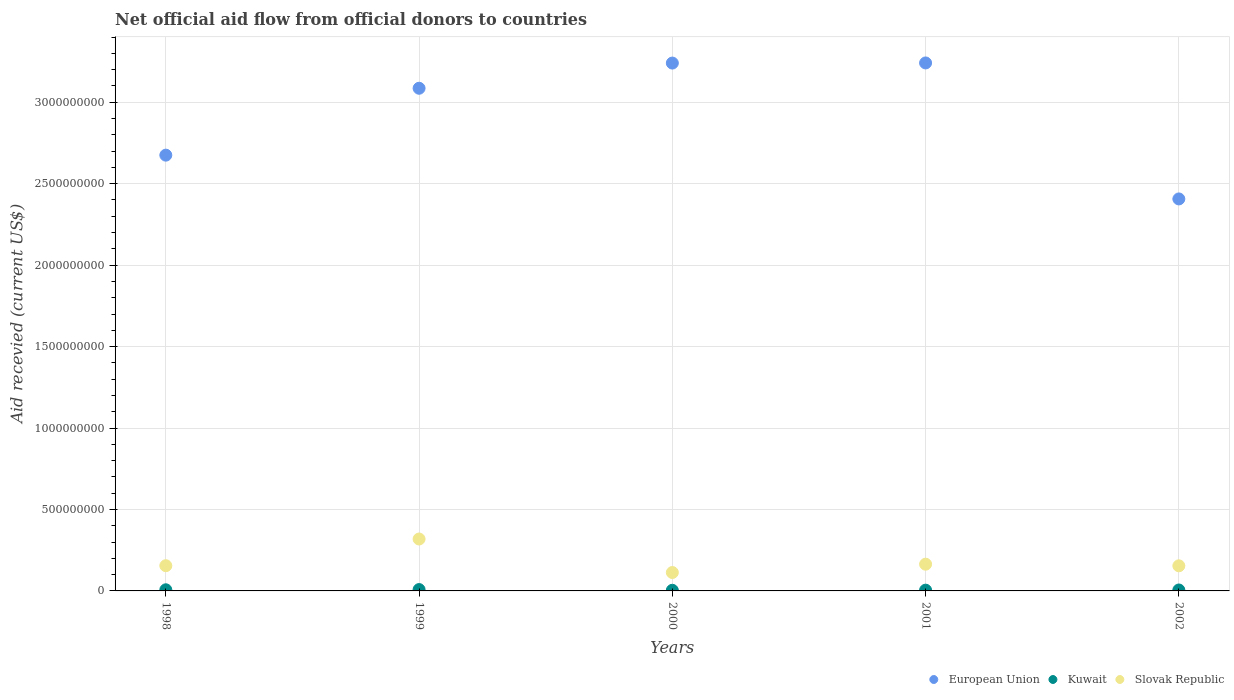How many different coloured dotlines are there?
Offer a terse response. 3. Is the number of dotlines equal to the number of legend labels?
Ensure brevity in your answer.  Yes. What is the total aid received in Slovak Republic in 2002?
Ensure brevity in your answer.  1.54e+08. Across all years, what is the maximum total aid received in European Union?
Provide a short and direct response. 3.24e+09. Across all years, what is the minimum total aid received in Kuwait?
Your answer should be compact. 3.89e+06. In which year was the total aid received in Slovak Republic maximum?
Your answer should be compact. 1999. In which year was the total aid received in Slovak Republic minimum?
Provide a succinct answer. 2000. What is the total total aid received in European Union in the graph?
Your answer should be compact. 1.46e+1. What is the difference between the total aid received in European Union in 1999 and that in 2001?
Your answer should be very brief. -1.55e+08. What is the difference between the total aid received in Kuwait in 1998 and the total aid received in Slovak Republic in 2000?
Provide a succinct answer. -1.06e+08. What is the average total aid received in Slovak Republic per year?
Provide a short and direct response. 1.81e+08. In the year 1999, what is the difference between the total aid received in Kuwait and total aid received in Slovak Republic?
Keep it short and to the point. -3.10e+08. In how many years, is the total aid received in European Union greater than 1400000000 US$?
Your response must be concise. 5. What is the ratio of the total aid received in Kuwait in 1999 to that in 2001?
Offer a very short reply. 1.78. Is the total aid received in Slovak Republic in 2000 less than that in 2001?
Provide a short and direct response. Yes. What is the difference between the highest and the second highest total aid received in Slovak Republic?
Provide a succinct answer. 1.55e+08. What is the difference between the highest and the lowest total aid received in Slovak Republic?
Provide a succinct answer. 2.06e+08. In how many years, is the total aid received in European Union greater than the average total aid received in European Union taken over all years?
Provide a short and direct response. 3. Does the total aid received in Kuwait monotonically increase over the years?
Offer a terse response. No. Is the total aid received in Kuwait strictly greater than the total aid received in European Union over the years?
Your answer should be compact. No. Is the total aid received in European Union strictly less than the total aid received in Slovak Republic over the years?
Provide a short and direct response. No. How many dotlines are there?
Offer a terse response. 3. How many years are there in the graph?
Make the answer very short. 5. What is the difference between two consecutive major ticks on the Y-axis?
Provide a short and direct response. 5.00e+08. Does the graph contain grids?
Make the answer very short. Yes. Where does the legend appear in the graph?
Your answer should be compact. Bottom right. How many legend labels are there?
Give a very brief answer. 3. How are the legend labels stacked?
Provide a short and direct response. Horizontal. What is the title of the graph?
Ensure brevity in your answer.  Net official aid flow from official donors to countries. Does "Cabo Verde" appear as one of the legend labels in the graph?
Your response must be concise. No. What is the label or title of the Y-axis?
Keep it short and to the point. Aid recevied (current US$). What is the Aid recevied (current US$) of European Union in 1998?
Your answer should be compact. 2.68e+09. What is the Aid recevied (current US$) of Kuwait in 1998?
Ensure brevity in your answer.  6.99e+06. What is the Aid recevied (current US$) in Slovak Republic in 1998?
Make the answer very short. 1.55e+08. What is the Aid recevied (current US$) of European Union in 1999?
Give a very brief answer. 3.09e+09. What is the Aid recevied (current US$) in Kuwait in 1999?
Make the answer very short. 8.33e+06. What is the Aid recevied (current US$) in Slovak Republic in 1999?
Keep it short and to the point. 3.19e+08. What is the Aid recevied (current US$) of European Union in 2000?
Offer a very short reply. 3.24e+09. What is the Aid recevied (current US$) in Kuwait in 2000?
Make the answer very short. 3.89e+06. What is the Aid recevied (current US$) of Slovak Republic in 2000?
Your answer should be very brief. 1.13e+08. What is the Aid recevied (current US$) in European Union in 2001?
Provide a succinct answer. 3.24e+09. What is the Aid recevied (current US$) in Kuwait in 2001?
Provide a succinct answer. 4.69e+06. What is the Aid recevied (current US$) of Slovak Republic in 2001?
Offer a terse response. 1.64e+08. What is the Aid recevied (current US$) in European Union in 2002?
Your response must be concise. 2.41e+09. What is the Aid recevied (current US$) in Kuwait in 2002?
Provide a succinct answer. 5.71e+06. What is the Aid recevied (current US$) in Slovak Republic in 2002?
Keep it short and to the point. 1.54e+08. Across all years, what is the maximum Aid recevied (current US$) of European Union?
Give a very brief answer. 3.24e+09. Across all years, what is the maximum Aid recevied (current US$) in Kuwait?
Make the answer very short. 8.33e+06. Across all years, what is the maximum Aid recevied (current US$) in Slovak Republic?
Provide a succinct answer. 3.19e+08. Across all years, what is the minimum Aid recevied (current US$) of European Union?
Your answer should be very brief. 2.41e+09. Across all years, what is the minimum Aid recevied (current US$) of Kuwait?
Your answer should be very brief. 3.89e+06. Across all years, what is the minimum Aid recevied (current US$) of Slovak Republic?
Give a very brief answer. 1.13e+08. What is the total Aid recevied (current US$) of European Union in the graph?
Make the answer very short. 1.46e+1. What is the total Aid recevied (current US$) of Kuwait in the graph?
Your response must be concise. 2.96e+07. What is the total Aid recevied (current US$) of Slovak Republic in the graph?
Provide a succinct answer. 9.05e+08. What is the difference between the Aid recevied (current US$) in European Union in 1998 and that in 1999?
Your answer should be very brief. -4.11e+08. What is the difference between the Aid recevied (current US$) in Kuwait in 1998 and that in 1999?
Offer a terse response. -1.34e+06. What is the difference between the Aid recevied (current US$) in Slovak Republic in 1998 and that in 1999?
Provide a succinct answer. -1.64e+08. What is the difference between the Aid recevied (current US$) of European Union in 1998 and that in 2000?
Your answer should be compact. -5.65e+08. What is the difference between the Aid recevied (current US$) of Kuwait in 1998 and that in 2000?
Your answer should be compact. 3.10e+06. What is the difference between the Aid recevied (current US$) of Slovak Republic in 1998 and that in 2000?
Provide a succinct answer. 4.18e+07. What is the difference between the Aid recevied (current US$) of European Union in 1998 and that in 2001?
Offer a very short reply. -5.66e+08. What is the difference between the Aid recevied (current US$) of Kuwait in 1998 and that in 2001?
Your answer should be very brief. 2.30e+06. What is the difference between the Aid recevied (current US$) of Slovak Republic in 1998 and that in 2001?
Your response must be concise. -9.22e+06. What is the difference between the Aid recevied (current US$) in European Union in 1998 and that in 2002?
Give a very brief answer. 2.69e+08. What is the difference between the Aid recevied (current US$) in Kuwait in 1998 and that in 2002?
Offer a terse response. 1.28e+06. What is the difference between the Aid recevied (current US$) of European Union in 1999 and that in 2000?
Your response must be concise. -1.55e+08. What is the difference between the Aid recevied (current US$) of Kuwait in 1999 and that in 2000?
Your response must be concise. 4.44e+06. What is the difference between the Aid recevied (current US$) of Slovak Republic in 1999 and that in 2000?
Give a very brief answer. 2.06e+08. What is the difference between the Aid recevied (current US$) in European Union in 1999 and that in 2001?
Make the answer very short. -1.55e+08. What is the difference between the Aid recevied (current US$) of Kuwait in 1999 and that in 2001?
Your response must be concise. 3.64e+06. What is the difference between the Aid recevied (current US$) in Slovak Republic in 1999 and that in 2001?
Offer a terse response. 1.55e+08. What is the difference between the Aid recevied (current US$) in European Union in 1999 and that in 2002?
Provide a succinct answer. 6.79e+08. What is the difference between the Aid recevied (current US$) in Kuwait in 1999 and that in 2002?
Ensure brevity in your answer.  2.62e+06. What is the difference between the Aid recevied (current US$) in Slovak Republic in 1999 and that in 2002?
Offer a terse response. 1.65e+08. What is the difference between the Aid recevied (current US$) in European Union in 2000 and that in 2001?
Provide a short and direct response. -7.70e+05. What is the difference between the Aid recevied (current US$) in Kuwait in 2000 and that in 2001?
Give a very brief answer. -8.00e+05. What is the difference between the Aid recevied (current US$) in Slovak Republic in 2000 and that in 2001?
Your answer should be very brief. -5.10e+07. What is the difference between the Aid recevied (current US$) of European Union in 2000 and that in 2002?
Your answer should be compact. 8.34e+08. What is the difference between the Aid recevied (current US$) in Kuwait in 2000 and that in 2002?
Offer a terse response. -1.82e+06. What is the difference between the Aid recevied (current US$) of Slovak Republic in 2000 and that in 2002?
Keep it short and to the point. -4.11e+07. What is the difference between the Aid recevied (current US$) of European Union in 2001 and that in 2002?
Your answer should be compact. 8.35e+08. What is the difference between the Aid recevied (current US$) of Kuwait in 2001 and that in 2002?
Make the answer very short. -1.02e+06. What is the difference between the Aid recevied (current US$) of Slovak Republic in 2001 and that in 2002?
Ensure brevity in your answer.  9.92e+06. What is the difference between the Aid recevied (current US$) of European Union in 1998 and the Aid recevied (current US$) of Kuwait in 1999?
Your response must be concise. 2.67e+09. What is the difference between the Aid recevied (current US$) of European Union in 1998 and the Aid recevied (current US$) of Slovak Republic in 1999?
Offer a very short reply. 2.36e+09. What is the difference between the Aid recevied (current US$) in Kuwait in 1998 and the Aid recevied (current US$) in Slovak Republic in 1999?
Ensure brevity in your answer.  -3.12e+08. What is the difference between the Aid recevied (current US$) of European Union in 1998 and the Aid recevied (current US$) of Kuwait in 2000?
Your answer should be very brief. 2.67e+09. What is the difference between the Aid recevied (current US$) in European Union in 1998 and the Aid recevied (current US$) in Slovak Republic in 2000?
Provide a short and direct response. 2.56e+09. What is the difference between the Aid recevied (current US$) of Kuwait in 1998 and the Aid recevied (current US$) of Slovak Republic in 2000?
Offer a very short reply. -1.06e+08. What is the difference between the Aid recevied (current US$) in European Union in 1998 and the Aid recevied (current US$) in Kuwait in 2001?
Ensure brevity in your answer.  2.67e+09. What is the difference between the Aid recevied (current US$) of European Union in 1998 and the Aid recevied (current US$) of Slovak Republic in 2001?
Ensure brevity in your answer.  2.51e+09. What is the difference between the Aid recevied (current US$) of Kuwait in 1998 and the Aid recevied (current US$) of Slovak Republic in 2001?
Give a very brief answer. -1.57e+08. What is the difference between the Aid recevied (current US$) in European Union in 1998 and the Aid recevied (current US$) in Kuwait in 2002?
Your answer should be very brief. 2.67e+09. What is the difference between the Aid recevied (current US$) in European Union in 1998 and the Aid recevied (current US$) in Slovak Republic in 2002?
Ensure brevity in your answer.  2.52e+09. What is the difference between the Aid recevied (current US$) in Kuwait in 1998 and the Aid recevied (current US$) in Slovak Republic in 2002?
Give a very brief answer. -1.47e+08. What is the difference between the Aid recevied (current US$) of European Union in 1999 and the Aid recevied (current US$) of Kuwait in 2000?
Keep it short and to the point. 3.08e+09. What is the difference between the Aid recevied (current US$) of European Union in 1999 and the Aid recevied (current US$) of Slovak Republic in 2000?
Your response must be concise. 2.97e+09. What is the difference between the Aid recevied (current US$) in Kuwait in 1999 and the Aid recevied (current US$) in Slovak Republic in 2000?
Ensure brevity in your answer.  -1.05e+08. What is the difference between the Aid recevied (current US$) of European Union in 1999 and the Aid recevied (current US$) of Kuwait in 2001?
Offer a very short reply. 3.08e+09. What is the difference between the Aid recevied (current US$) in European Union in 1999 and the Aid recevied (current US$) in Slovak Republic in 2001?
Give a very brief answer. 2.92e+09. What is the difference between the Aid recevied (current US$) of Kuwait in 1999 and the Aid recevied (current US$) of Slovak Republic in 2001?
Your answer should be very brief. -1.56e+08. What is the difference between the Aid recevied (current US$) of European Union in 1999 and the Aid recevied (current US$) of Kuwait in 2002?
Your response must be concise. 3.08e+09. What is the difference between the Aid recevied (current US$) in European Union in 1999 and the Aid recevied (current US$) in Slovak Republic in 2002?
Provide a short and direct response. 2.93e+09. What is the difference between the Aid recevied (current US$) in Kuwait in 1999 and the Aid recevied (current US$) in Slovak Republic in 2002?
Provide a succinct answer. -1.46e+08. What is the difference between the Aid recevied (current US$) in European Union in 2000 and the Aid recevied (current US$) in Kuwait in 2001?
Offer a very short reply. 3.24e+09. What is the difference between the Aid recevied (current US$) of European Union in 2000 and the Aid recevied (current US$) of Slovak Republic in 2001?
Give a very brief answer. 3.08e+09. What is the difference between the Aid recevied (current US$) of Kuwait in 2000 and the Aid recevied (current US$) of Slovak Republic in 2001?
Keep it short and to the point. -1.60e+08. What is the difference between the Aid recevied (current US$) in European Union in 2000 and the Aid recevied (current US$) in Kuwait in 2002?
Give a very brief answer. 3.23e+09. What is the difference between the Aid recevied (current US$) of European Union in 2000 and the Aid recevied (current US$) of Slovak Republic in 2002?
Ensure brevity in your answer.  3.09e+09. What is the difference between the Aid recevied (current US$) of Kuwait in 2000 and the Aid recevied (current US$) of Slovak Republic in 2002?
Ensure brevity in your answer.  -1.50e+08. What is the difference between the Aid recevied (current US$) in European Union in 2001 and the Aid recevied (current US$) in Kuwait in 2002?
Offer a very short reply. 3.24e+09. What is the difference between the Aid recevied (current US$) of European Union in 2001 and the Aid recevied (current US$) of Slovak Republic in 2002?
Provide a succinct answer. 3.09e+09. What is the difference between the Aid recevied (current US$) of Kuwait in 2001 and the Aid recevied (current US$) of Slovak Republic in 2002?
Your response must be concise. -1.49e+08. What is the average Aid recevied (current US$) of European Union per year?
Your answer should be compact. 2.93e+09. What is the average Aid recevied (current US$) in Kuwait per year?
Give a very brief answer. 5.92e+06. What is the average Aid recevied (current US$) of Slovak Republic per year?
Your answer should be very brief. 1.81e+08. In the year 1998, what is the difference between the Aid recevied (current US$) in European Union and Aid recevied (current US$) in Kuwait?
Your answer should be very brief. 2.67e+09. In the year 1998, what is the difference between the Aid recevied (current US$) of European Union and Aid recevied (current US$) of Slovak Republic?
Make the answer very short. 2.52e+09. In the year 1998, what is the difference between the Aid recevied (current US$) in Kuwait and Aid recevied (current US$) in Slovak Republic?
Give a very brief answer. -1.48e+08. In the year 1999, what is the difference between the Aid recevied (current US$) in European Union and Aid recevied (current US$) in Kuwait?
Your response must be concise. 3.08e+09. In the year 1999, what is the difference between the Aid recevied (current US$) of European Union and Aid recevied (current US$) of Slovak Republic?
Offer a terse response. 2.77e+09. In the year 1999, what is the difference between the Aid recevied (current US$) in Kuwait and Aid recevied (current US$) in Slovak Republic?
Your answer should be compact. -3.10e+08. In the year 2000, what is the difference between the Aid recevied (current US$) of European Union and Aid recevied (current US$) of Kuwait?
Offer a terse response. 3.24e+09. In the year 2000, what is the difference between the Aid recevied (current US$) of European Union and Aid recevied (current US$) of Slovak Republic?
Provide a succinct answer. 3.13e+09. In the year 2000, what is the difference between the Aid recevied (current US$) of Kuwait and Aid recevied (current US$) of Slovak Republic?
Your response must be concise. -1.09e+08. In the year 2001, what is the difference between the Aid recevied (current US$) in European Union and Aid recevied (current US$) in Kuwait?
Your answer should be very brief. 3.24e+09. In the year 2001, what is the difference between the Aid recevied (current US$) in European Union and Aid recevied (current US$) in Slovak Republic?
Offer a terse response. 3.08e+09. In the year 2001, what is the difference between the Aid recevied (current US$) in Kuwait and Aid recevied (current US$) in Slovak Republic?
Give a very brief answer. -1.59e+08. In the year 2002, what is the difference between the Aid recevied (current US$) in European Union and Aid recevied (current US$) in Kuwait?
Keep it short and to the point. 2.40e+09. In the year 2002, what is the difference between the Aid recevied (current US$) in European Union and Aid recevied (current US$) in Slovak Republic?
Give a very brief answer. 2.25e+09. In the year 2002, what is the difference between the Aid recevied (current US$) in Kuwait and Aid recevied (current US$) in Slovak Republic?
Your answer should be compact. -1.48e+08. What is the ratio of the Aid recevied (current US$) of European Union in 1998 to that in 1999?
Your answer should be compact. 0.87. What is the ratio of the Aid recevied (current US$) in Kuwait in 1998 to that in 1999?
Provide a succinct answer. 0.84. What is the ratio of the Aid recevied (current US$) of Slovak Republic in 1998 to that in 1999?
Ensure brevity in your answer.  0.49. What is the ratio of the Aid recevied (current US$) of European Union in 1998 to that in 2000?
Your answer should be compact. 0.83. What is the ratio of the Aid recevied (current US$) in Kuwait in 1998 to that in 2000?
Make the answer very short. 1.8. What is the ratio of the Aid recevied (current US$) in Slovak Republic in 1998 to that in 2000?
Your answer should be very brief. 1.37. What is the ratio of the Aid recevied (current US$) of European Union in 1998 to that in 2001?
Your answer should be compact. 0.83. What is the ratio of the Aid recevied (current US$) in Kuwait in 1998 to that in 2001?
Ensure brevity in your answer.  1.49. What is the ratio of the Aid recevied (current US$) of Slovak Republic in 1998 to that in 2001?
Your answer should be very brief. 0.94. What is the ratio of the Aid recevied (current US$) of European Union in 1998 to that in 2002?
Give a very brief answer. 1.11. What is the ratio of the Aid recevied (current US$) in Kuwait in 1998 to that in 2002?
Your response must be concise. 1.22. What is the ratio of the Aid recevied (current US$) in European Union in 1999 to that in 2000?
Keep it short and to the point. 0.95. What is the ratio of the Aid recevied (current US$) in Kuwait in 1999 to that in 2000?
Your answer should be compact. 2.14. What is the ratio of the Aid recevied (current US$) in Slovak Republic in 1999 to that in 2000?
Give a very brief answer. 2.82. What is the ratio of the Aid recevied (current US$) in European Union in 1999 to that in 2001?
Offer a terse response. 0.95. What is the ratio of the Aid recevied (current US$) in Kuwait in 1999 to that in 2001?
Your answer should be compact. 1.78. What is the ratio of the Aid recevied (current US$) in Slovak Republic in 1999 to that in 2001?
Your answer should be very brief. 1.94. What is the ratio of the Aid recevied (current US$) in European Union in 1999 to that in 2002?
Your response must be concise. 1.28. What is the ratio of the Aid recevied (current US$) in Kuwait in 1999 to that in 2002?
Give a very brief answer. 1.46. What is the ratio of the Aid recevied (current US$) of Slovak Republic in 1999 to that in 2002?
Your answer should be very brief. 2.07. What is the ratio of the Aid recevied (current US$) in European Union in 2000 to that in 2001?
Ensure brevity in your answer.  1. What is the ratio of the Aid recevied (current US$) in Kuwait in 2000 to that in 2001?
Your answer should be very brief. 0.83. What is the ratio of the Aid recevied (current US$) in Slovak Republic in 2000 to that in 2001?
Your answer should be compact. 0.69. What is the ratio of the Aid recevied (current US$) in European Union in 2000 to that in 2002?
Provide a short and direct response. 1.35. What is the ratio of the Aid recevied (current US$) of Kuwait in 2000 to that in 2002?
Make the answer very short. 0.68. What is the ratio of the Aid recevied (current US$) in Slovak Republic in 2000 to that in 2002?
Make the answer very short. 0.73. What is the ratio of the Aid recevied (current US$) in European Union in 2001 to that in 2002?
Provide a succinct answer. 1.35. What is the ratio of the Aid recevied (current US$) in Kuwait in 2001 to that in 2002?
Keep it short and to the point. 0.82. What is the ratio of the Aid recevied (current US$) in Slovak Republic in 2001 to that in 2002?
Offer a very short reply. 1.06. What is the difference between the highest and the second highest Aid recevied (current US$) in European Union?
Keep it short and to the point. 7.70e+05. What is the difference between the highest and the second highest Aid recevied (current US$) of Kuwait?
Ensure brevity in your answer.  1.34e+06. What is the difference between the highest and the second highest Aid recevied (current US$) in Slovak Republic?
Offer a very short reply. 1.55e+08. What is the difference between the highest and the lowest Aid recevied (current US$) of European Union?
Your response must be concise. 8.35e+08. What is the difference between the highest and the lowest Aid recevied (current US$) of Kuwait?
Offer a terse response. 4.44e+06. What is the difference between the highest and the lowest Aid recevied (current US$) in Slovak Republic?
Your response must be concise. 2.06e+08. 